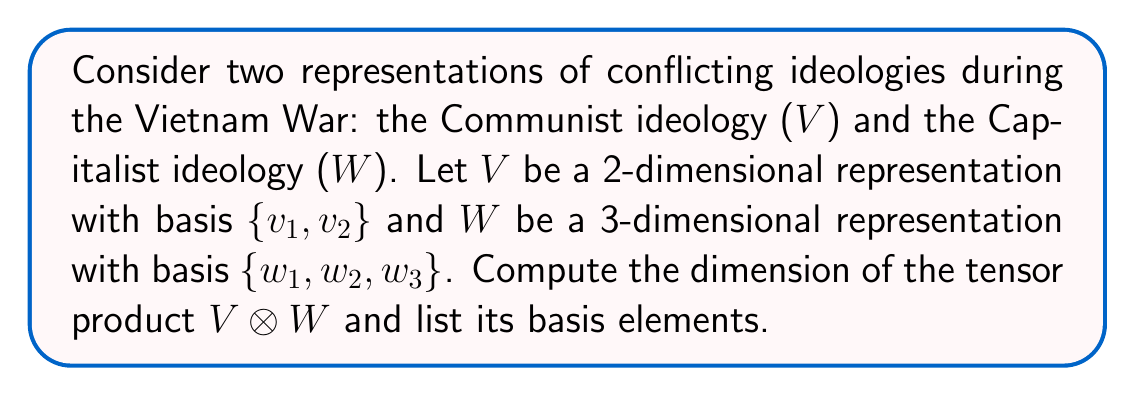Could you help me with this problem? To solve this problem, we'll follow these steps:

1) The dimension of a tensor product is the product of the dimensions of the individual vector spaces:
   $$\dim(V \otimes W) = \dim(V) \cdot \dim(W)$$

2) We're given:
   $$\dim(V) = 2$$
   $$\dim(W) = 3$$

3) Therefore:
   $$\dim(V \otimes W) = 2 \cdot 3 = 6$$

4) The basis of the tensor product consists of all possible tensor products of basis vectors from $V$ and $W$. Given the bases:
   $$V: \{v_1, v_2\}$$
   $$W: \{w_1, w_2, w_3\}$$

5) The basis of $V \otimes W$ is:
   $$\{v_1 \otimes w_1, v_1 \otimes w_2, v_1 \otimes w_3, v_2 \otimes w_1, v_2 \otimes w_2, v_2 \otimes w_3\}$$

This result represents all possible combinations of ideological elements from both sides, which could be interpreted as the complex interplay of Communist and Capitalist ideologies during the Vietnam War.
Answer: Dimension: 6
Basis: $\{v_1 \otimes w_1, v_1 \otimes w_2, v_1 \otimes w_3, v_2 \otimes w_1, v_2 \otimes w_2, v_2 \otimes w_3\}$ 